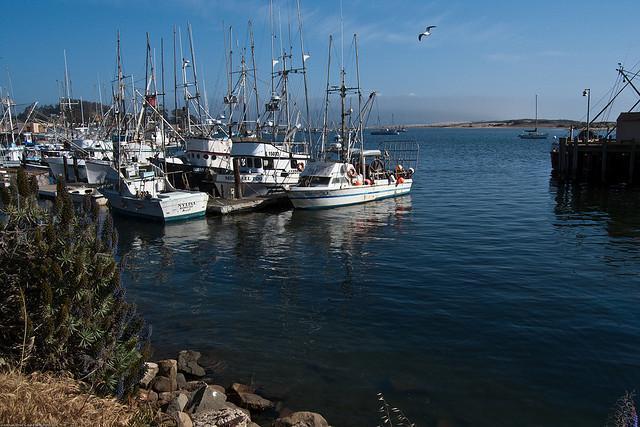Why are the boats stationary?
Pick the right solution, then justify: 'Answer: answer
Rationale: rationale.'
Options: Unseaworthy, no gas, docked, bad weather. Answer: docked.
Rationale: These boats have their sails down and are unmoving arranged around the dock. 